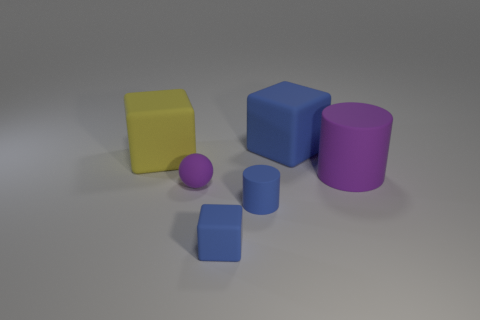Subtract all blue cylinders. How many blue blocks are left? 2 Subtract all blue rubber blocks. How many blocks are left? 1 Add 4 purple spheres. How many objects exist? 10 Subtract all small brown cubes. Subtract all yellow matte objects. How many objects are left? 5 Add 1 big matte objects. How many big matte objects are left? 4 Add 2 big blue things. How many big blue things exist? 3 Subtract 1 purple spheres. How many objects are left? 5 Subtract all spheres. How many objects are left? 5 